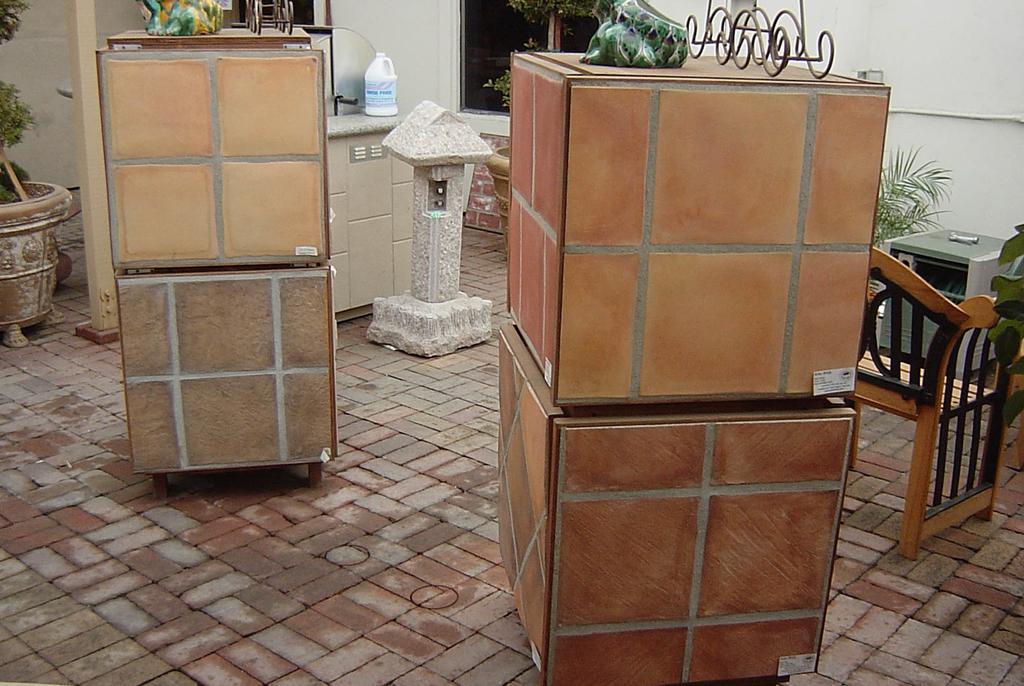Describe this image in one or two sentences. In this image, I can see the boxes with objects on it, a chair and few other objects on the floor. On the left side of the image, there is a flower pot with a plant. In the background, I can see a window and the wall. 